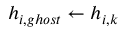<formula> <loc_0><loc_0><loc_500><loc_500>h _ { i , g h o s t } \leftarrow h _ { i , k }</formula> 